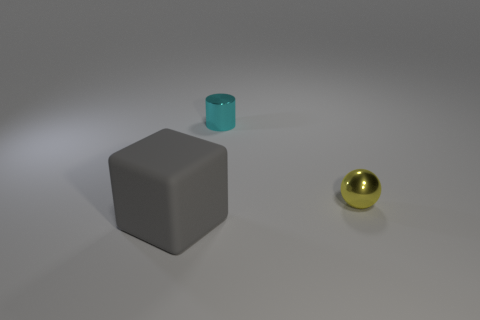How many green objects are metal balls or tiny metallic cylinders? 0 